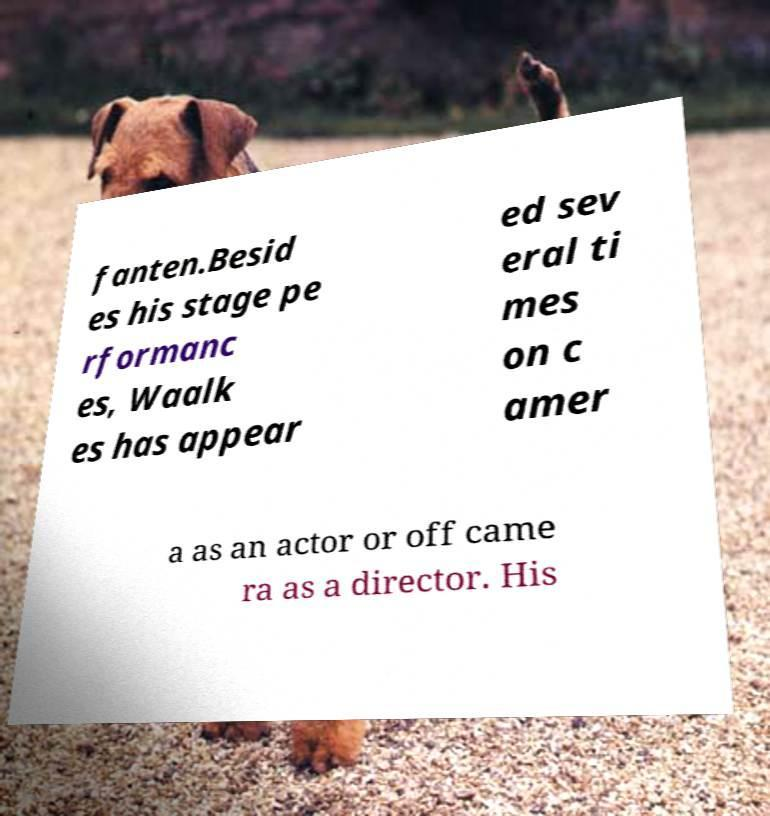There's text embedded in this image that I need extracted. Can you transcribe it verbatim? fanten.Besid es his stage pe rformanc es, Waalk es has appear ed sev eral ti mes on c amer a as an actor or off came ra as a director. His 